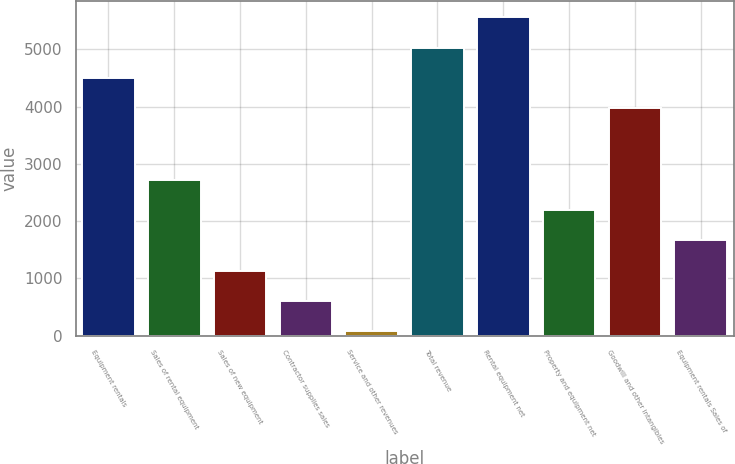Convert chart to OTSL. <chart><loc_0><loc_0><loc_500><loc_500><bar_chart><fcel>Equipment rentals<fcel>Sales of rental equipment<fcel>Sales of new equipment<fcel>Contractor supplies sales<fcel>Service and other revenues<fcel>Total revenue<fcel>Rental equipment net<fcel>Property and equipment net<fcel>Goodwill and other intangibles<fcel>Equipment rentals Sales of<nl><fcel>4500.6<fcel>2726<fcel>1137.2<fcel>607.6<fcel>78<fcel>5030.2<fcel>5559.8<fcel>2196.4<fcel>3971<fcel>1666.8<nl></chart> 